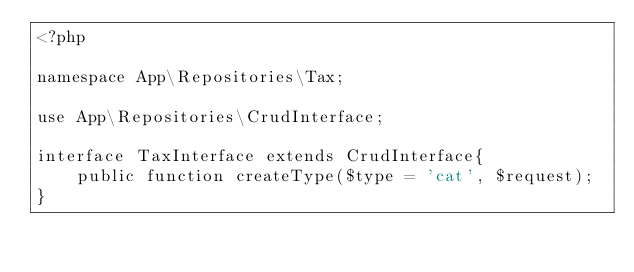Convert code to text. <code><loc_0><loc_0><loc_500><loc_500><_PHP_><?php

namespace App\Repositories\Tax;

use App\Repositories\CrudInterface;

interface TaxInterface extends CrudInterface{
    public function createType($type = 'cat', $request);
}
</code> 